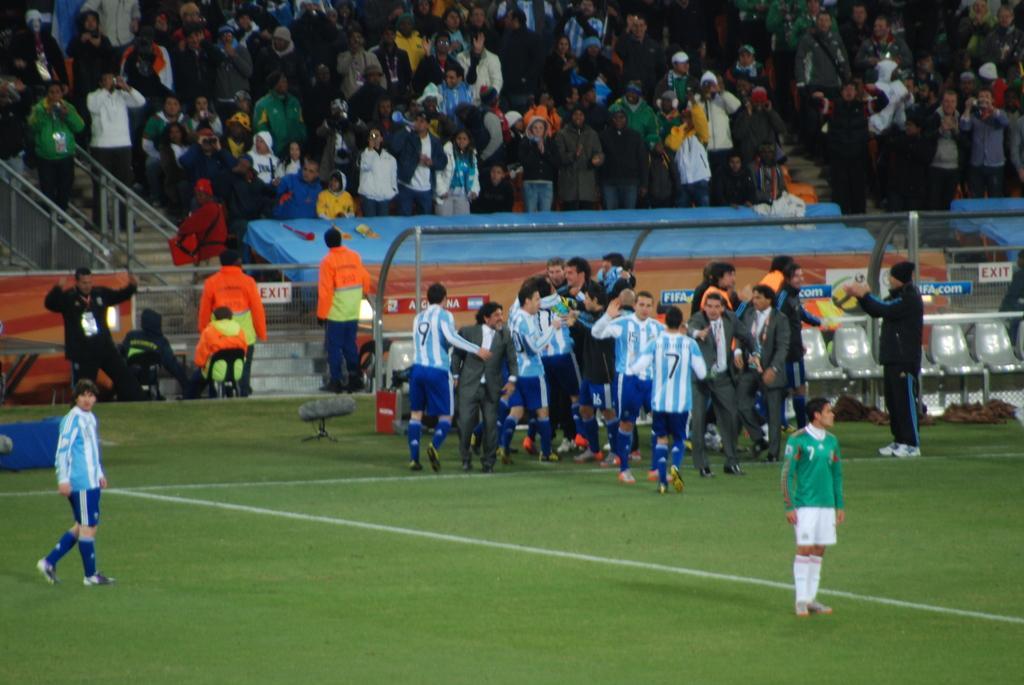Describe this image in one or two sentences. In this image, we can see a group of people are on the grass. Few people are standing and walking. Here we can see seats, shed, some objects. Background there are few roads, sign boards, banners, stairs, cloth, few people. 